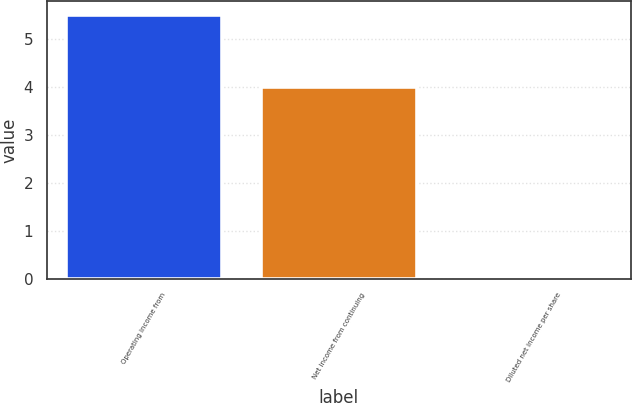Convert chart to OTSL. <chart><loc_0><loc_0><loc_500><loc_500><bar_chart><fcel>Operating income from<fcel>Net income from continuing<fcel>Diluted net income per share<nl><fcel>5.5<fcel>4<fcel>0.01<nl></chart> 